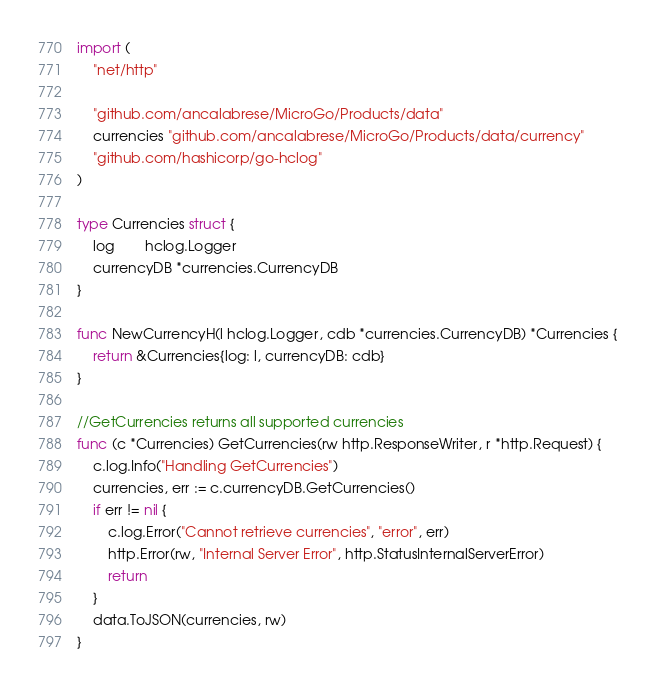Convert code to text. <code><loc_0><loc_0><loc_500><loc_500><_Go_>import (
	"net/http"

	"github.com/ancalabrese/MicroGo/Products/data"
	currencies "github.com/ancalabrese/MicroGo/Products/data/currency"
	"github.com/hashicorp/go-hclog"
)

type Currencies struct {
	log        hclog.Logger
	currencyDB *currencies.CurrencyDB
}

func NewCurrencyH(l hclog.Logger, cdb *currencies.CurrencyDB) *Currencies {
	return &Currencies{log: l, currencyDB: cdb}
}

//GetCurrencies returns all supported currencies
func (c *Currencies) GetCurrencies(rw http.ResponseWriter, r *http.Request) {
	c.log.Info("Handling GetCurrencies")
	currencies, err := c.currencyDB.GetCurrencies()
	if err != nil {
		c.log.Error("Cannot retrieve currencies", "error", err)
		http.Error(rw, "Internal Server Error", http.StatusInternalServerError)
		return
	}
	data.ToJSON(currencies, rw)
}
</code> 